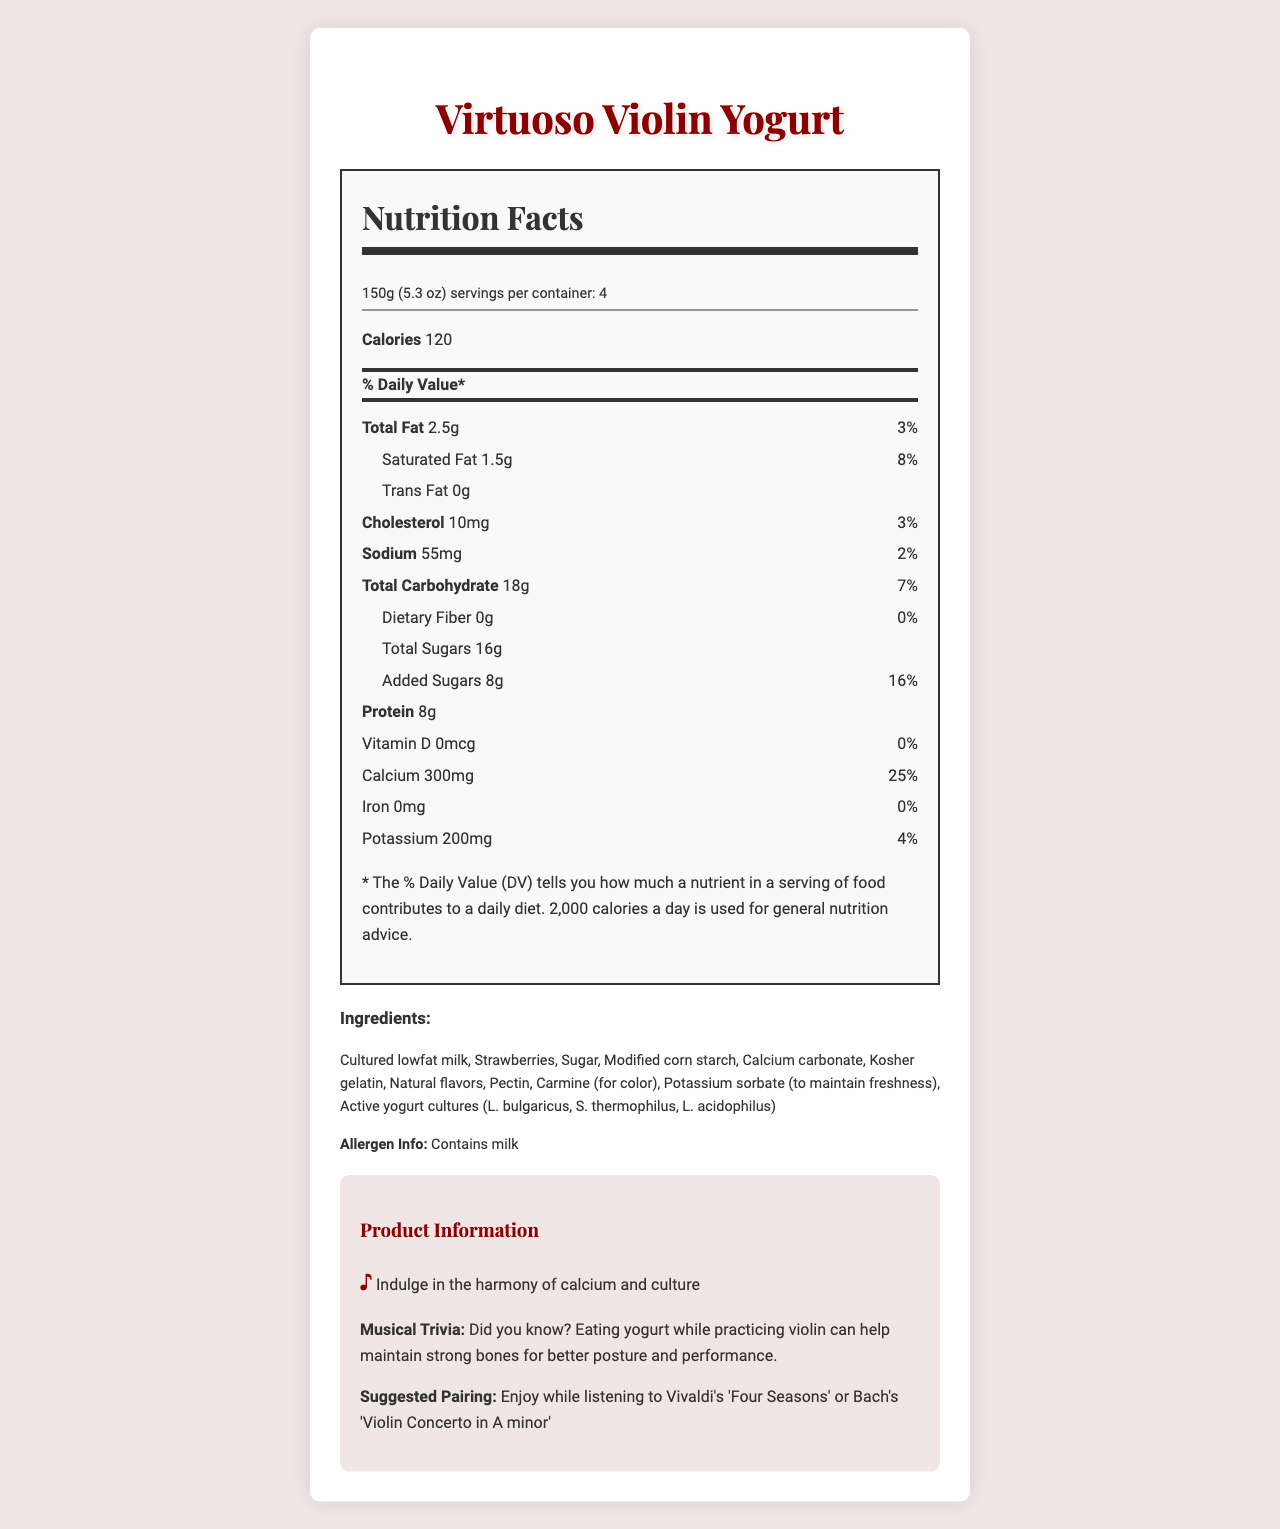what is the serving size of Virtuoso Violin Yogurt? The document shows the serving size listed as "150g (5.3 oz)" under the nutrition facts section.
Answer: 150g (5.3 oz) how many calories are there per serving? The Nutrition Facts section indicates that each serving contains 120 calories.
Answer: 120 what percentage of the daily value for calcium does a serving of this yogurt provide? The nutrition facts box states that one serving provides 25% of the daily value for calcium.
Answer: 25% what is the total amount of sugars in a serving? The total sugars amount is given as 16g in the nutrition facts.
Answer: 16g what are the first three ingredients listed? The ingredients section lists them in order as "Cultured lowfat milk, Strawberries, Sugar," suggesting these are the primary constituents.
Answer: Cultured lowfat milk, Strawberries, Sugar which of the following is NOT an ingredient in Virtuoso Violin Yogurt? A. Carmine B. Strawberry puree C. Modified corn starch D. Kosher gelatin The document lists strawberries as an ingredient but not specifically "strawberry puree."
Answer: B. Strawberry puree what is the daily value percentage for total fat per serving? A. 5% B. 3% C. 8% D. 10% The nutrition facts indicate that the total fat amount is 2.5g, which is 3% of the daily value.
Answer: B. 3% does this product contain any dietary fiber? According to the document, the amount of dietary fiber per serving is 0g, with a daily value percentage of 0%.
Answer: No is there any information in the document related to classical music? The document contains musical trivia, a suggested pairing with classical music, and classical music-themed packaging.
Answer: Yes summarize the main idea of the document. The document outlines the nutrition facts and ingredients of Virtuoso Violin Yogurt, emphasizing its calcium content. The packaging features a violin and musical notes, appealing to young musicians. It also includes a musical trivia, suggesting that yogurt consumption can support strong bones for better posture during violin practice. Additionally, there's a suggested pairing with classical music pieces.
Answer: Answer describes a calcium-rich yogurt snack designed for young musicians and classical music enthusiasts, providing detailed nutrition information, ingredients, and packaging that highlights classical music themes. how much vitamin D is in each serving of the yogurt? The document states that the amount of vitamin D per serving is 0mcg.
Answer: 0mcg what is the suggested pairing for enjoying this yogurt? The suggested pairing is included in the product information section.
Answer: Enjoy while listening to Vivaldi's 'Four Seasons' or Bach's 'Violin Concerto in A minor' how many servings are there in a container of Virtuoso Violin Yogurt? The serving info indicates there are 4 servings per container.
Answer: 4 what is the product tagline? The tagline is found in the product information section.
Answer: "Indulge in the harmony of calcium and culture" how much protein does one serving contain? The nutrition facts indicate that each serving contains 8g of protein.
Answer: 8g which cultures are found in the yogurt? The ingredients list mentions these active yogurt cultures in the yogurt.
Answer: L. bulgaricus, S. thermophilus, L. acidophilus how much potassium is in one serving, and what is the daily value percentage? The nutrition facts list 200mg of potassium per serving, making up 4% of the daily value.
Answer: 200mg, 4% how does the packaging look according to the description? The packaging description in the document provides these details.
Answer: Classical music-themed packaging featuring a watercolor illustration of a violin and musical notes on a soft pastel pink background reminiscent of strawberry yogurt is there any iron in the yogurt? The document states that the amount of iron per serving is 0mg.
Answer: No what is the significance of calcium in this product's context? The musical trivia section mentions that eating yogurt can help maintain strong bones, which is advantageous for better posture and performance on the violin.
Answer: It suggests that calcium helps maintain strong bones, beneficial for better posture while playing the violin. What is the reason for the product targeting young musicians? While the document links yogurt's calcium content to strong bones and better posture for violinists, it does not explicitly state why young musicians are specifically targeted over other age groups.
Answer: Not enough information 